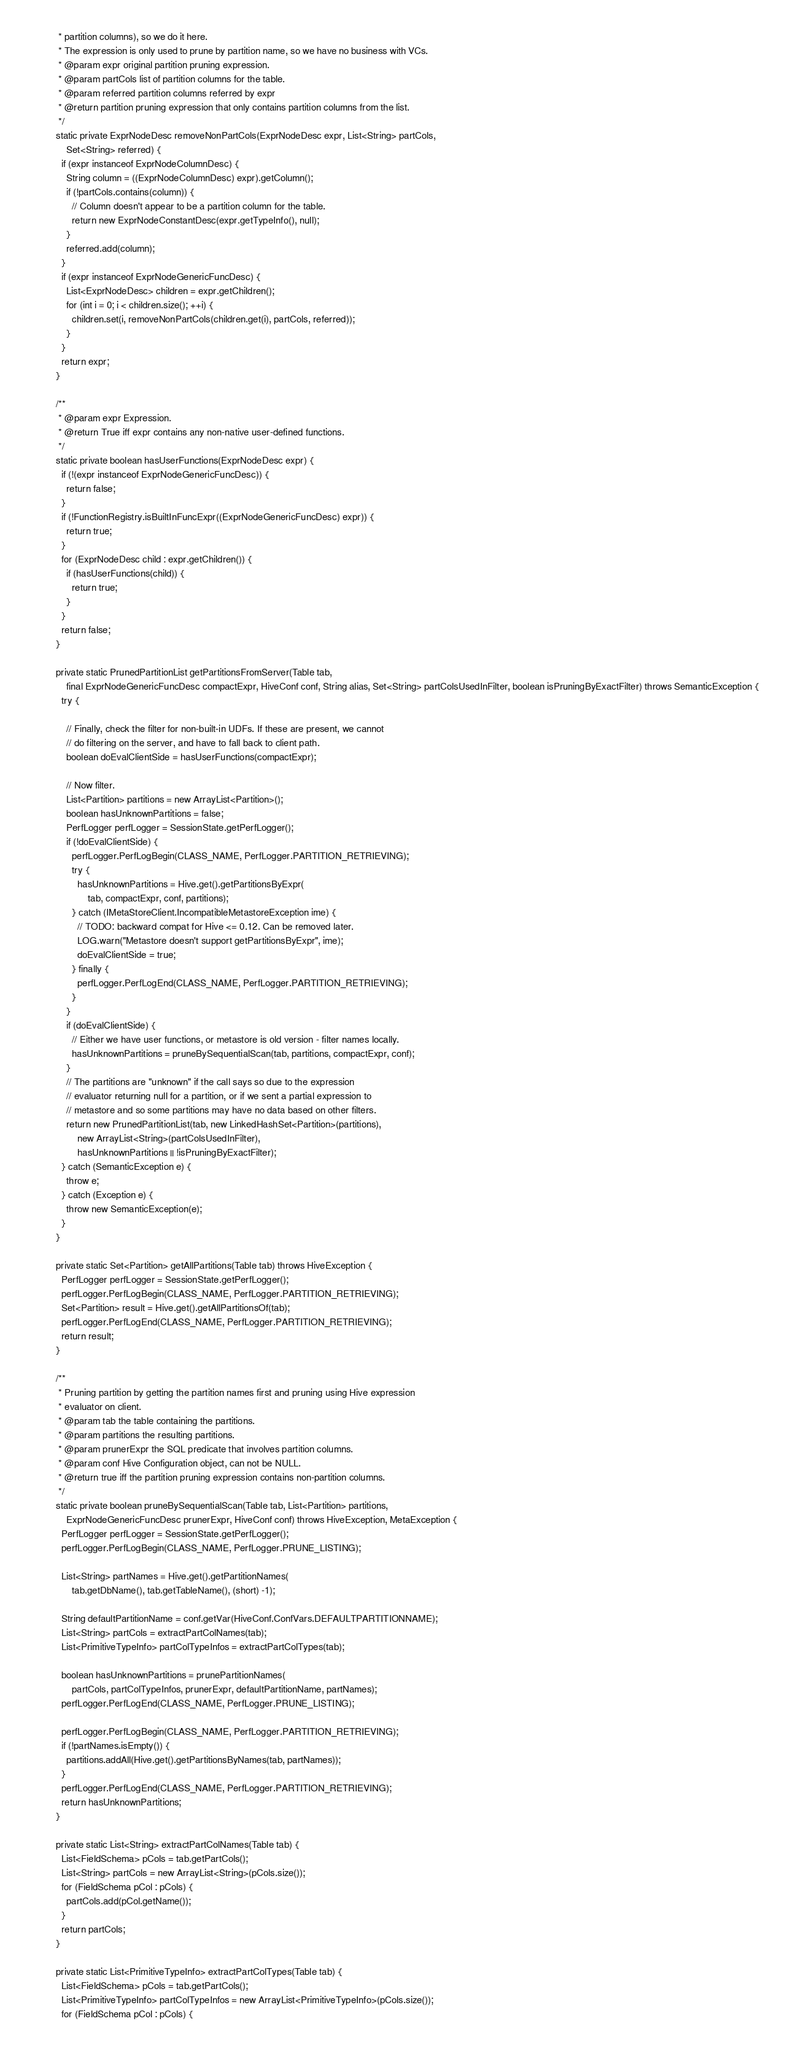<code> <loc_0><loc_0><loc_500><loc_500><_Java_>   * partition columns), so we do it here.
   * The expression is only used to prune by partition name, so we have no business with VCs.
   * @param expr original partition pruning expression.
   * @param partCols list of partition columns for the table.
   * @param referred partition columns referred by expr
   * @return partition pruning expression that only contains partition columns from the list.
   */
  static private ExprNodeDesc removeNonPartCols(ExprNodeDesc expr, List<String> partCols,
      Set<String> referred) {
    if (expr instanceof ExprNodeColumnDesc) {
      String column = ((ExprNodeColumnDesc) expr).getColumn();
      if (!partCols.contains(column)) {
        // Column doesn't appear to be a partition column for the table.
        return new ExprNodeConstantDesc(expr.getTypeInfo(), null);
      }
      referred.add(column);
    }
    if (expr instanceof ExprNodeGenericFuncDesc) {
      List<ExprNodeDesc> children = expr.getChildren();
      for (int i = 0; i < children.size(); ++i) {
        children.set(i, removeNonPartCols(children.get(i), partCols, referred));
      }
    }
    return expr;
  }

  /**
   * @param expr Expression.
   * @return True iff expr contains any non-native user-defined functions.
   */
  static private boolean hasUserFunctions(ExprNodeDesc expr) {
    if (!(expr instanceof ExprNodeGenericFuncDesc)) {
      return false;
    }
    if (!FunctionRegistry.isBuiltInFuncExpr((ExprNodeGenericFuncDesc) expr)) {
      return true;
    }
    for (ExprNodeDesc child : expr.getChildren()) {
      if (hasUserFunctions(child)) {
        return true;
      }
    }
    return false;
  }

  private static PrunedPartitionList getPartitionsFromServer(Table tab,
      final ExprNodeGenericFuncDesc compactExpr, HiveConf conf, String alias, Set<String> partColsUsedInFilter, boolean isPruningByExactFilter) throws SemanticException {
    try {

      // Finally, check the filter for non-built-in UDFs. If these are present, we cannot
      // do filtering on the server, and have to fall back to client path.
      boolean doEvalClientSide = hasUserFunctions(compactExpr);

      // Now filter.
      List<Partition> partitions = new ArrayList<Partition>();
      boolean hasUnknownPartitions = false;
      PerfLogger perfLogger = SessionState.getPerfLogger();
      if (!doEvalClientSide) {
        perfLogger.PerfLogBegin(CLASS_NAME, PerfLogger.PARTITION_RETRIEVING);
        try {
          hasUnknownPartitions = Hive.get().getPartitionsByExpr(
              tab, compactExpr, conf, partitions);
        } catch (IMetaStoreClient.IncompatibleMetastoreException ime) {
          // TODO: backward compat for Hive <= 0.12. Can be removed later.
          LOG.warn("Metastore doesn't support getPartitionsByExpr", ime);
          doEvalClientSide = true;
        } finally {
          perfLogger.PerfLogEnd(CLASS_NAME, PerfLogger.PARTITION_RETRIEVING);
        }
      }
      if (doEvalClientSide) {
        // Either we have user functions, or metastore is old version - filter names locally.
        hasUnknownPartitions = pruneBySequentialScan(tab, partitions, compactExpr, conf);
      }
      // The partitions are "unknown" if the call says so due to the expression
      // evaluator returning null for a partition, or if we sent a partial expression to
      // metastore and so some partitions may have no data based on other filters.
      return new PrunedPartitionList(tab, new LinkedHashSet<Partition>(partitions),
          new ArrayList<String>(partColsUsedInFilter),
          hasUnknownPartitions || !isPruningByExactFilter);
    } catch (SemanticException e) {
      throw e;
    } catch (Exception e) {
      throw new SemanticException(e);
    }
  }

  private static Set<Partition> getAllPartitions(Table tab) throws HiveException {
    PerfLogger perfLogger = SessionState.getPerfLogger();
    perfLogger.PerfLogBegin(CLASS_NAME, PerfLogger.PARTITION_RETRIEVING);
    Set<Partition> result = Hive.get().getAllPartitionsOf(tab);
    perfLogger.PerfLogEnd(CLASS_NAME, PerfLogger.PARTITION_RETRIEVING);
    return result;
  }

  /**
   * Pruning partition by getting the partition names first and pruning using Hive expression
   * evaluator on client.
   * @param tab the table containing the partitions.
   * @param partitions the resulting partitions.
   * @param prunerExpr the SQL predicate that involves partition columns.
   * @param conf Hive Configuration object, can not be NULL.
   * @return true iff the partition pruning expression contains non-partition columns.
   */
  static private boolean pruneBySequentialScan(Table tab, List<Partition> partitions,
      ExprNodeGenericFuncDesc prunerExpr, HiveConf conf) throws HiveException, MetaException {
    PerfLogger perfLogger = SessionState.getPerfLogger();
    perfLogger.PerfLogBegin(CLASS_NAME, PerfLogger.PRUNE_LISTING);

    List<String> partNames = Hive.get().getPartitionNames(
        tab.getDbName(), tab.getTableName(), (short) -1);

    String defaultPartitionName = conf.getVar(HiveConf.ConfVars.DEFAULTPARTITIONNAME);
    List<String> partCols = extractPartColNames(tab);
    List<PrimitiveTypeInfo> partColTypeInfos = extractPartColTypes(tab);

    boolean hasUnknownPartitions = prunePartitionNames(
        partCols, partColTypeInfos, prunerExpr, defaultPartitionName, partNames);
    perfLogger.PerfLogEnd(CLASS_NAME, PerfLogger.PRUNE_LISTING);

    perfLogger.PerfLogBegin(CLASS_NAME, PerfLogger.PARTITION_RETRIEVING);
    if (!partNames.isEmpty()) {
      partitions.addAll(Hive.get().getPartitionsByNames(tab, partNames));
    }
    perfLogger.PerfLogEnd(CLASS_NAME, PerfLogger.PARTITION_RETRIEVING);
    return hasUnknownPartitions;
  }

  private static List<String> extractPartColNames(Table tab) {
    List<FieldSchema> pCols = tab.getPartCols();
    List<String> partCols = new ArrayList<String>(pCols.size());
    for (FieldSchema pCol : pCols) {
      partCols.add(pCol.getName());
    }
    return partCols;
  }

  private static List<PrimitiveTypeInfo> extractPartColTypes(Table tab) {
    List<FieldSchema> pCols = tab.getPartCols();
    List<PrimitiveTypeInfo> partColTypeInfos = new ArrayList<PrimitiveTypeInfo>(pCols.size());
    for (FieldSchema pCol : pCols) {</code> 